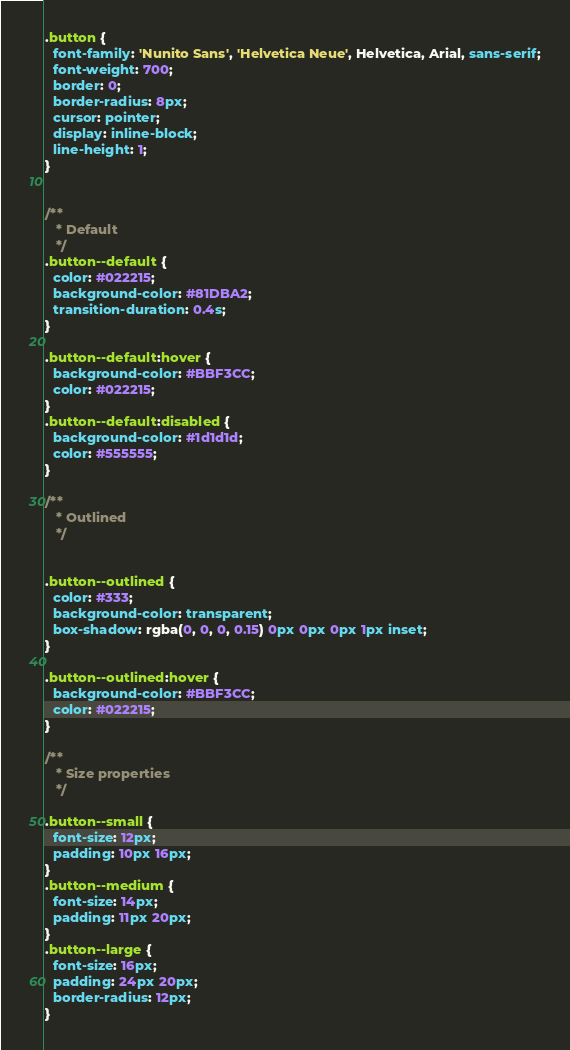<code> <loc_0><loc_0><loc_500><loc_500><_CSS_>.button {
  font-family: 'Nunito Sans', 'Helvetica Neue', Helvetica, Arial, sans-serif;
  font-weight: 700;
  border: 0;
  border-radius: 8px;
  cursor: pointer;
  display: inline-block;
  line-height: 1;
}


/**
   * Default
   */
.button--default {
  color: #022215;
  background-color: #81DBA2;
  transition-duration: 0.4s;
}

.button--default:hover {
  background-color: #BBF3CC;
  color: #022215;
}
.button--default:disabled {
  background-color: #1d1d1d;
  color: #555555;
}

/**
   * Outlined 
   */


.button--outlined {
  color: #333;
  background-color: transparent;
  box-shadow: rgba(0, 0, 0, 0.15) 0px 0px 0px 1px inset;
}

.button--outlined:hover {
  background-color: #BBF3CC;
  color: #022215;
}

/**
   * Size properties
   */

.button--small {
  font-size: 12px;
  padding: 10px 16px;
}
.button--medium {
  font-size: 14px;
  padding: 11px 20px;
}
.button--large {
  font-size: 16px;
  padding: 24px 20px;
  border-radius: 12px;
}
</code> 